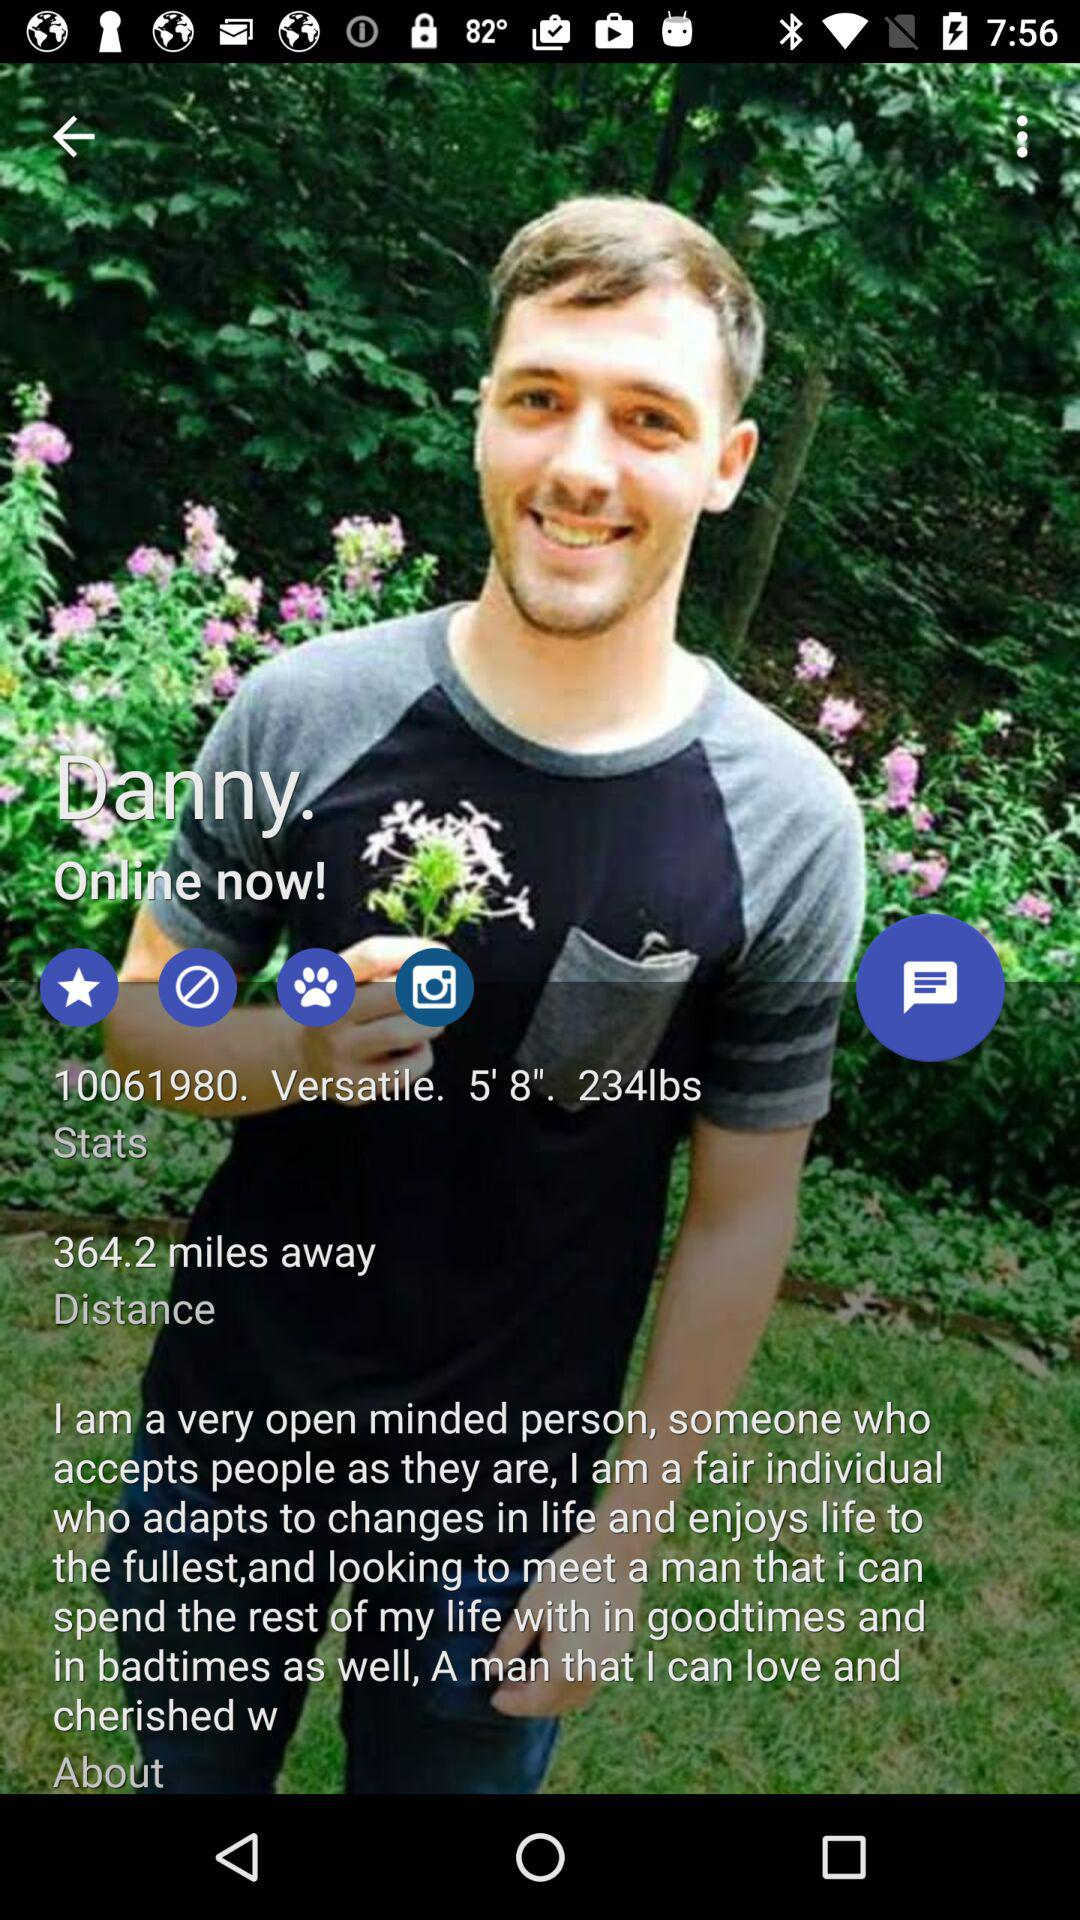What is the weight of Danny? Danny weighs 234 lbs. 